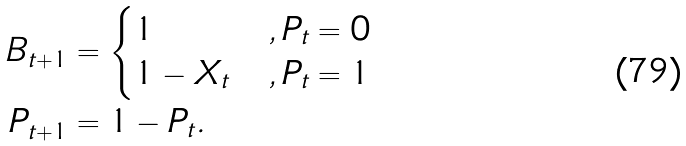Convert formula to latex. <formula><loc_0><loc_0><loc_500><loc_500>B _ { t + 1 } & = \begin{cases} 1 & , P _ { t } = 0 \\ 1 - X _ { t } & , P _ { t } = 1 \end{cases} \\ P _ { t + 1 } & = 1 - P _ { t } .</formula> 